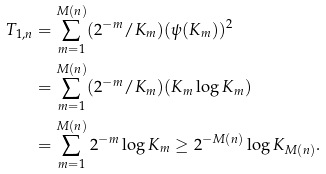<formula> <loc_0><loc_0><loc_500><loc_500>T _ { 1 , n } & = \sum _ { m = 1 } ^ { M ( n ) } ( 2 ^ { - m } / K _ { m } ) ( \psi ( K _ { m } ) ) ^ { 2 } \\ & = \sum _ { m = 1 } ^ { M ( n ) } ( 2 ^ { - m } / K _ { m } ) ( K _ { m } \log K _ { m } ) \\ & = \sum _ { m = 1 } ^ { M ( n ) } 2 ^ { - m } \log K _ { m } \geq 2 ^ { - M ( n ) } \log K _ { M ( n ) } .</formula> 